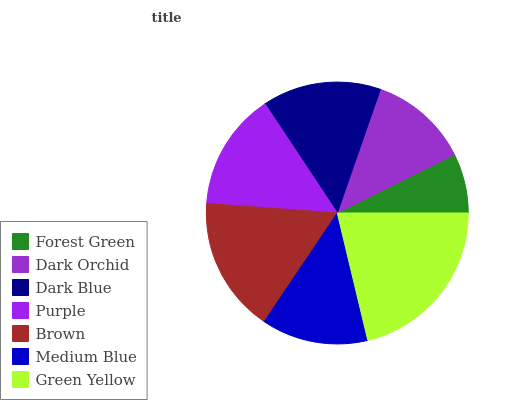Is Forest Green the minimum?
Answer yes or no. Yes. Is Green Yellow the maximum?
Answer yes or no. Yes. Is Dark Orchid the minimum?
Answer yes or no. No. Is Dark Orchid the maximum?
Answer yes or no. No. Is Dark Orchid greater than Forest Green?
Answer yes or no. Yes. Is Forest Green less than Dark Orchid?
Answer yes or no. Yes. Is Forest Green greater than Dark Orchid?
Answer yes or no. No. Is Dark Orchid less than Forest Green?
Answer yes or no. No. Is Purple the high median?
Answer yes or no. Yes. Is Purple the low median?
Answer yes or no. Yes. Is Brown the high median?
Answer yes or no. No. Is Dark Blue the low median?
Answer yes or no. No. 